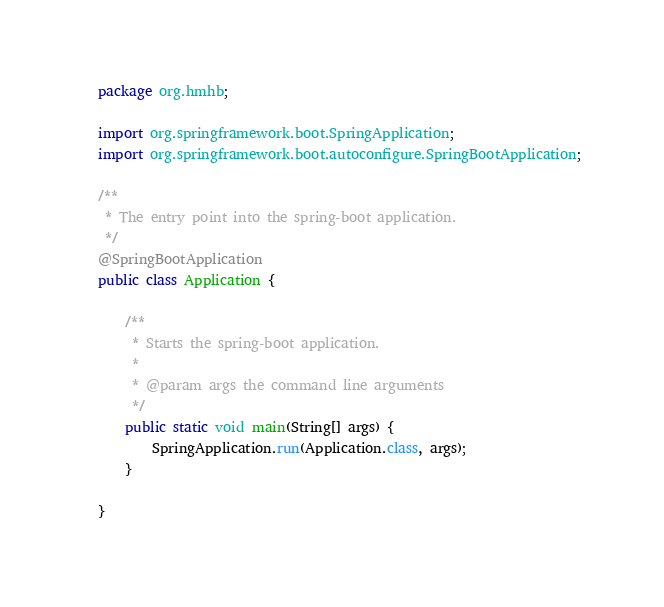Convert code to text. <code><loc_0><loc_0><loc_500><loc_500><_Java_>package org.hmhb;

import org.springframework.boot.SpringApplication;
import org.springframework.boot.autoconfigure.SpringBootApplication;

/**
 * The entry point into the spring-boot application.
 */
@SpringBootApplication
public class Application {

    /**
     * Starts the spring-boot application.
     *
     * @param args the command line arguments
     */
    public static void main(String[] args) {
        SpringApplication.run(Application.class, args);
    }

}
</code> 